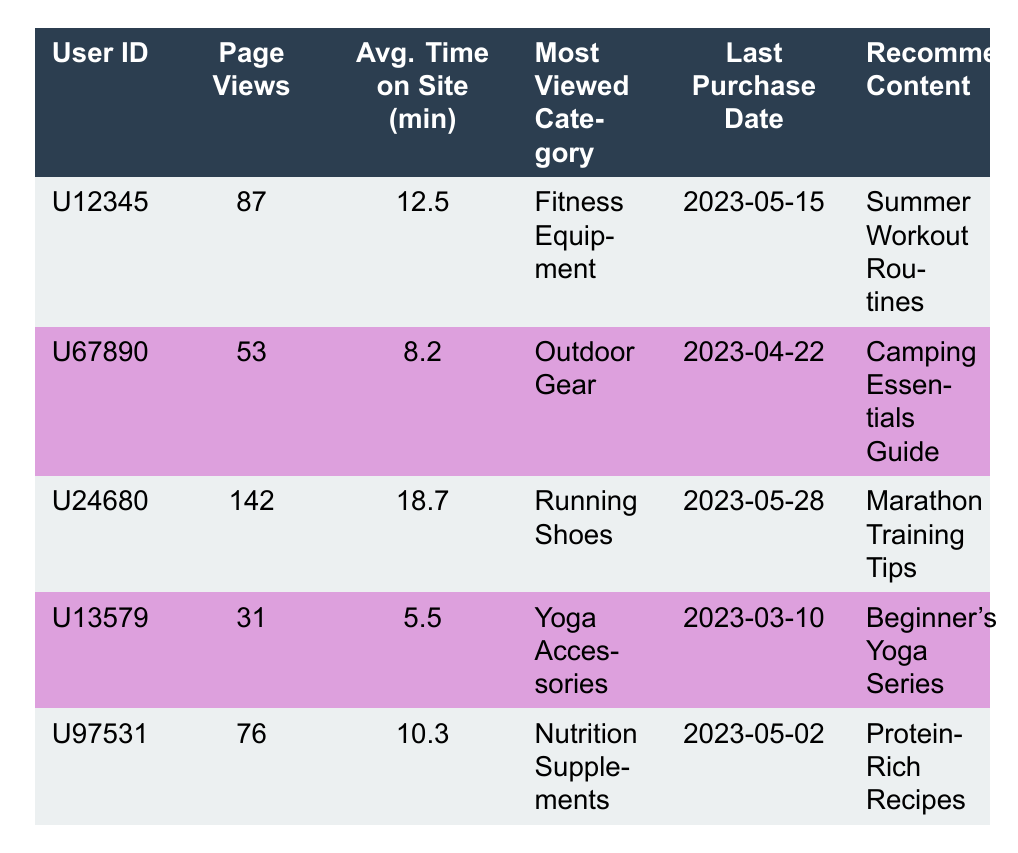What is the User ID of the user with the most page views? The user with the most page views can be found by comparing the "Page Views" column. The maximum value is 142, which corresponds to User ID U24680.
Answer: U24680 How many average minutes did User ID U13579 spend on the site? The average time spent on the site for User ID U13579 is given directly in the table under "Avg. Time on Site (min)", which shows 5.5 minutes.
Answer: 5.5 Which user has the most viewed category labeled as "Outdoor Gear"? In the "Most Viewed Category" column, User ID U67890 has "Outdoor Gear". This information is directly retrieved from the table.
Answer: U67890 Is there a user who last purchased on the date 2023-05-02? By checking the "Last Purchase Date" column, we see that User ID U97531 last purchased on 2023-05-02, confirming that they are the user in question.
Answer: Yes What is the average number of page views for all users? To compute the average, sum the page views: 87 + 53 + 142 + 31 + 76 = 389. There are 5 users, so the average is 389/5 = 77.8.
Answer: 77.8 How many users have an average time on site greater than 10 minutes? By checking the "Avg. Time on Site (min)" column, we find that U12345 (12.5), U24680 (18.7), and U97531 (10.3) have more than 10 minutes, totaling three users.
Answer: 3 What is the recommended content for the user with the ID U67890? The recommended content for User ID U67890 is listed in the "Recommended Content" column, which shows "Camping Essentials Guide."
Answer: Camping Essentials Guide Calculate the difference in page views between User ID U24680 and User ID U13579. User ID U24680 has 142 page views, while User ID U13579 has 31. The difference is calculated as 142 - 31 = 111.
Answer: 111 Has any user recommended content related to nutrition? User ID U97531 has recommended content that is related to nutrition with "Protein-Rich Recipes." This confirms the presence of such content for that user.
Answer: Yes 